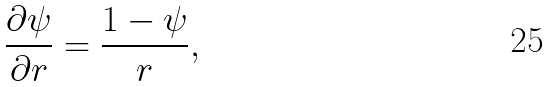Convert formula to latex. <formula><loc_0><loc_0><loc_500><loc_500>\frac { \partial \psi } { \partial r } = \frac { 1 - \psi } { r } ,</formula> 